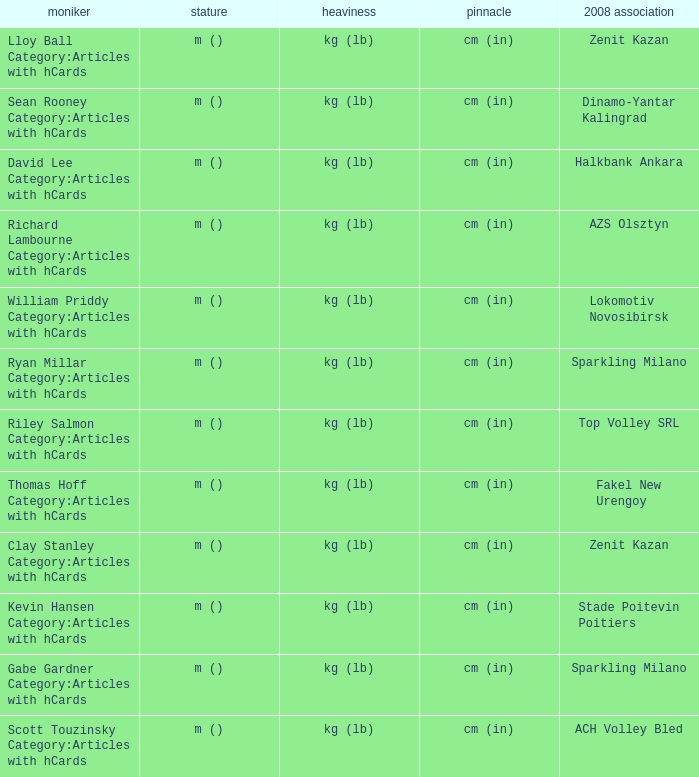What is the spike for the 2008 club of Lokomotiv Novosibirsk? Cm (in). 